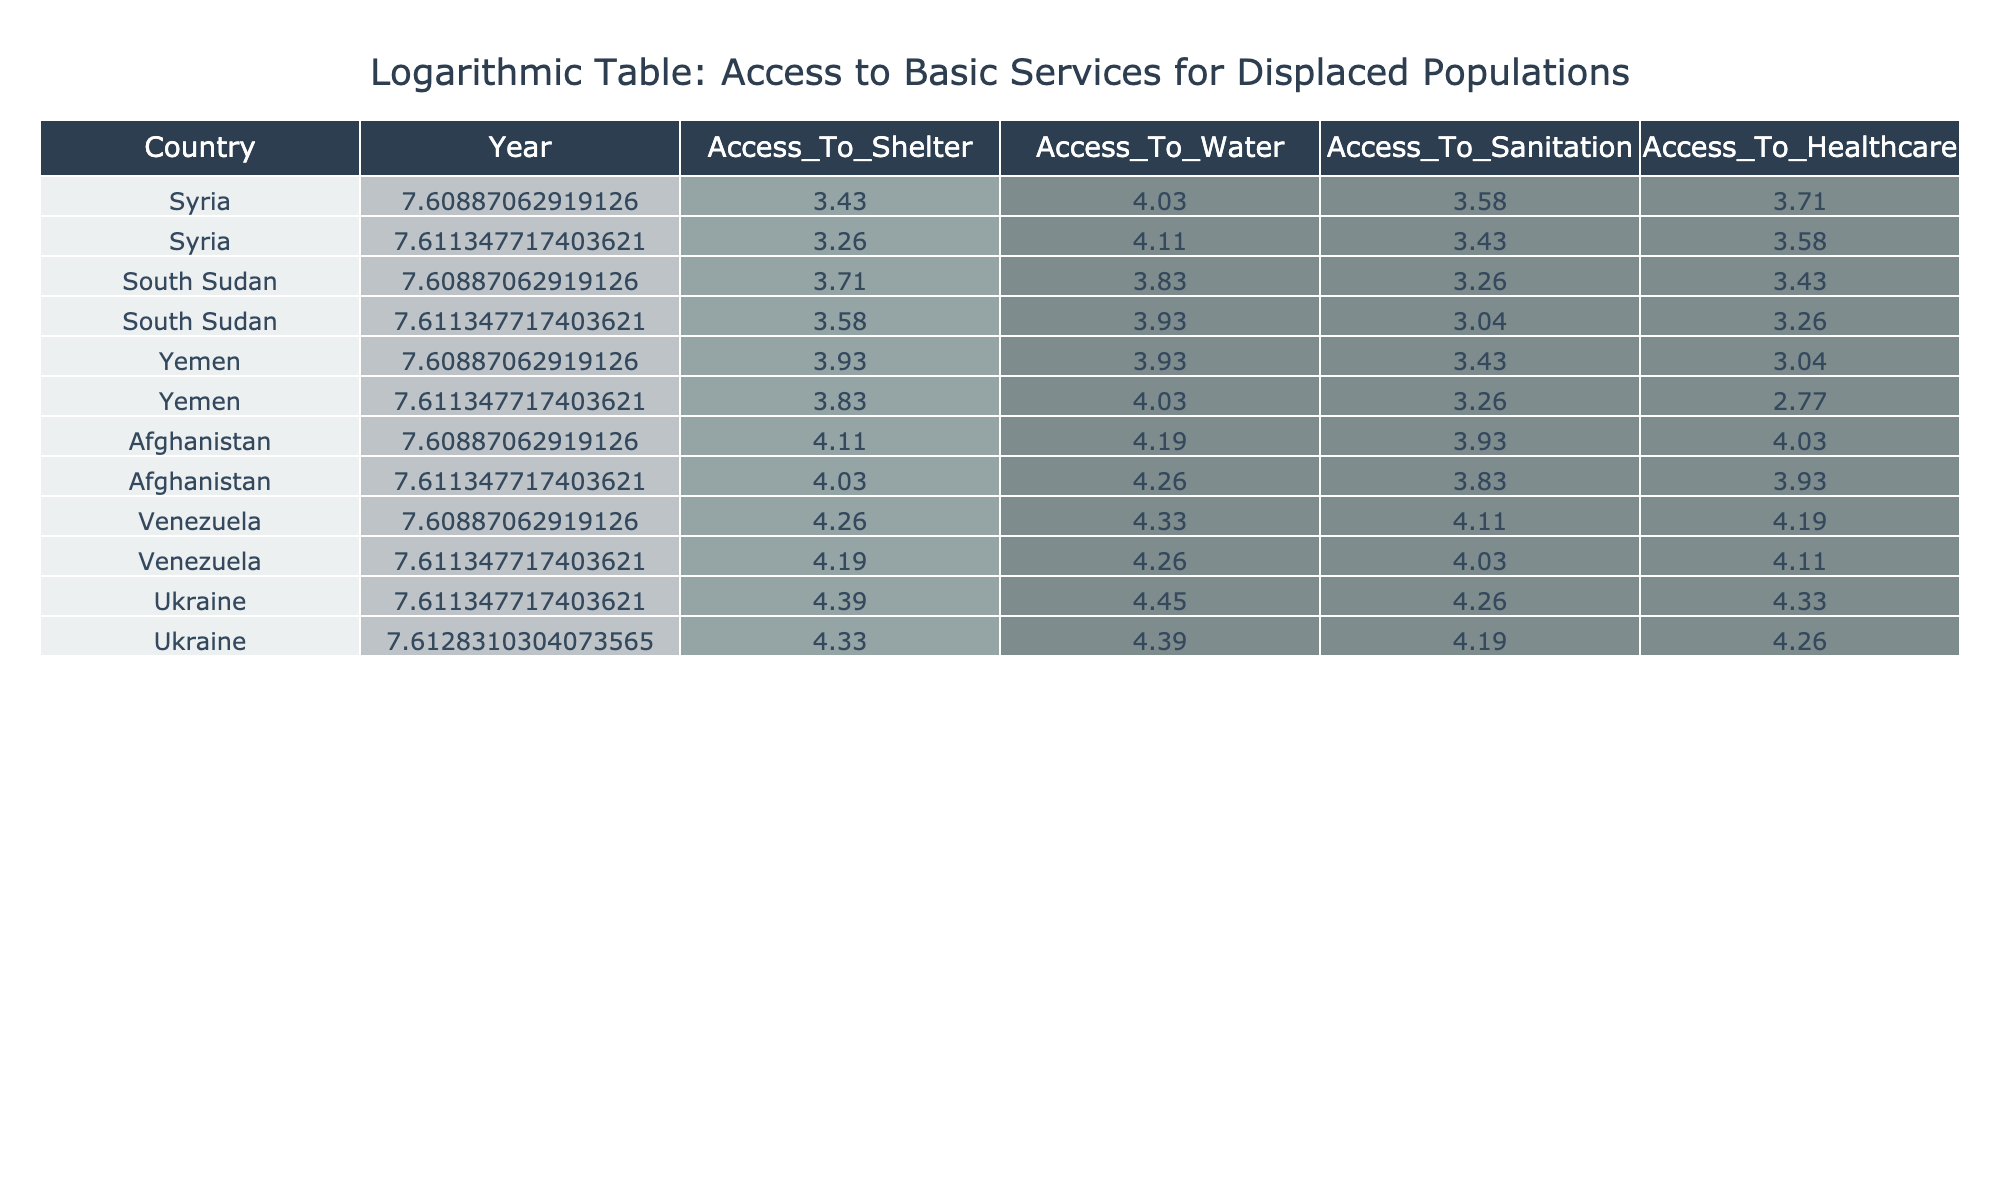What was the access to healthcare in Syria in 2015? According to the table, the access to healthcare in Syria for the year 2015 is listed as 40.
Answer: 40 What are the values for access to sanitation in South Sudan in 2020? The table indicates that the access to sanitation in South Sudan for 2020 is 20.
Answer: 20 What was the difference in access to shelter between Yemen in 2015 and 2020? From the table, the access to shelter in Yemen in 2015 is 50 and in 2020 is 45. The difference is calculated as 50 - 45 = 5.
Answer: 5 Is access to water getting better or worse for Afghanistan between 2015 and 2020? The table shows that in Afghanistan, access to water decreased from 65 in 2015 to 70 in 2020, indicating an improvement.
Answer: Better Which country had the highest access to healthcare in the year 2020? By reviewing the data, the highest access to healthcare in 2020 was in Ukraine, with a value of 75.
Answer: Ukraine What was the average access to sanitation across all years for Venezuela? To find the average access to sanitation for Venezuela, first sum up the values: (60 + 55) = 115. There are 2 years, so the average is 115 / 2 = 57.5.
Answer: 57.5 Which country saw the least access to shelter in 2020 compared to 2015? Analyzing the data, Syria saw a drop in access to shelter from 30 in 2015 to 25 in 2020, reflecting a decrease of 5. Other countries also saw drops, but Syria had the least access in the end.
Answer: Syria How does access to water in Ukraine compare to Yemen in 2020? In 2020, Ukraine had access to water at a level of 85, whereas Yemen had 55. This shows that Ukraine had significantly better access compared to Yemen.
Answer: Ukraine had better access What is the trend in access to sanitation or all countries from 2015 to 2020? By examining the data, we can see that the access to sanitation has tended to decrease in most countries from 2015 to 2020 except for Afghanistan, which remained stable or improved slightly. Thus, the overall trend shows a decline.
Answer: Decline 